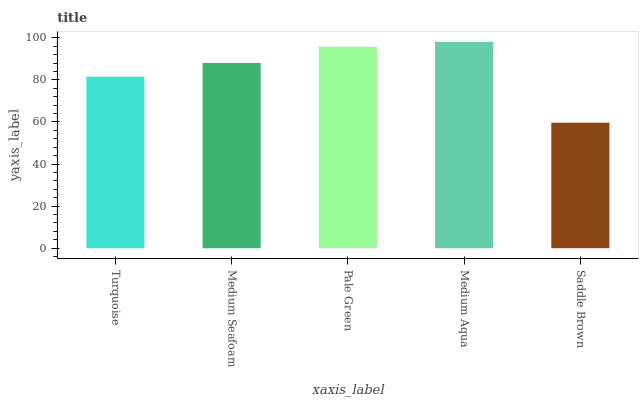Is Saddle Brown the minimum?
Answer yes or no. Yes. Is Medium Aqua the maximum?
Answer yes or no. Yes. Is Medium Seafoam the minimum?
Answer yes or no. No. Is Medium Seafoam the maximum?
Answer yes or no. No. Is Medium Seafoam greater than Turquoise?
Answer yes or no. Yes. Is Turquoise less than Medium Seafoam?
Answer yes or no. Yes. Is Turquoise greater than Medium Seafoam?
Answer yes or no. No. Is Medium Seafoam less than Turquoise?
Answer yes or no. No. Is Medium Seafoam the high median?
Answer yes or no. Yes. Is Medium Seafoam the low median?
Answer yes or no. Yes. Is Pale Green the high median?
Answer yes or no. No. Is Medium Aqua the low median?
Answer yes or no. No. 